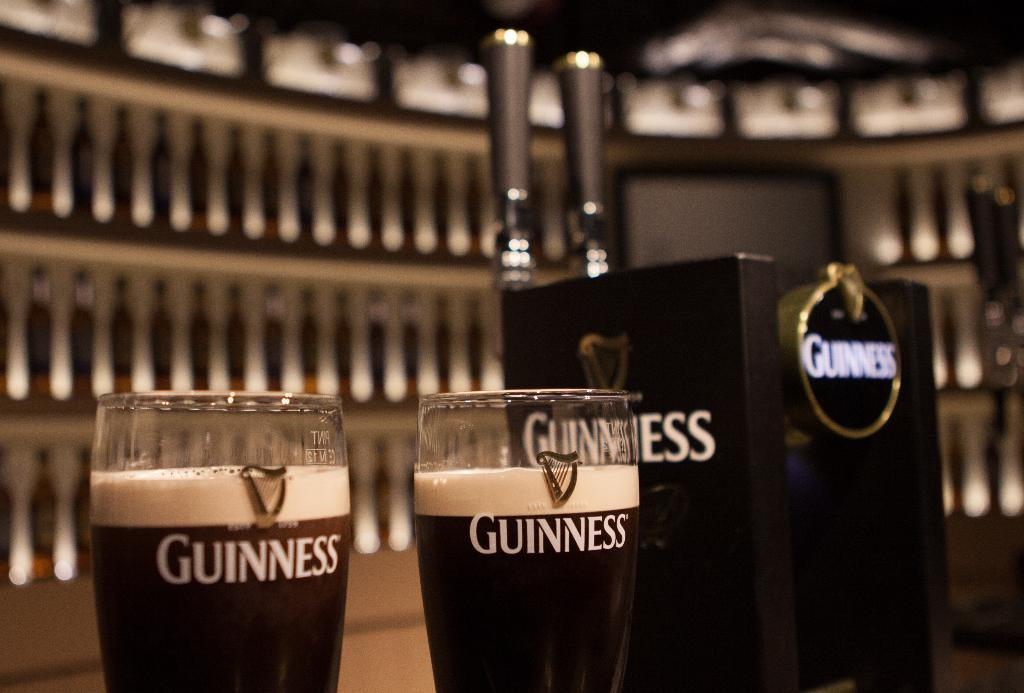<image>
Offer a succinct explanation of the picture presented. a bar showing two glasses of guiness and a guiness tap. 